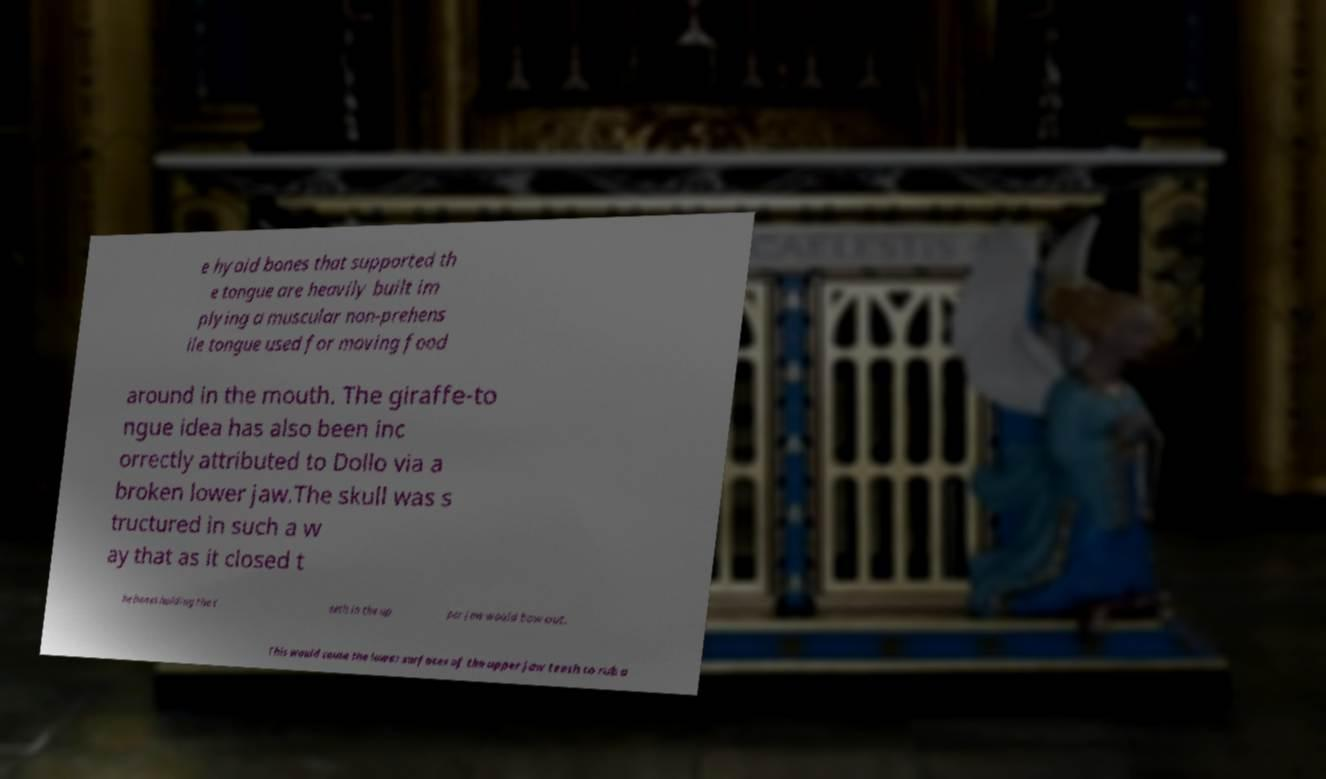Please read and relay the text visible in this image. What does it say? e hyoid bones that supported th e tongue are heavily built im plying a muscular non-prehens ile tongue used for moving food around in the mouth. The giraffe-to ngue idea has also been inc orrectly attributed to Dollo via a broken lower jaw.The skull was s tructured in such a w ay that as it closed t he bones holding the t eeth in the up per jaw would bow out. This would cause the lower surfaces of the upper jaw teeth to rub a 